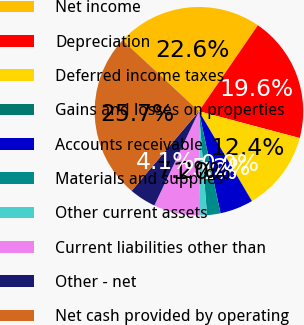<chart> <loc_0><loc_0><loc_500><loc_500><pie_chart><fcel>Net income<fcel>Depreciation<fcel>Deferred income taxes<fcel>Gains and losses on properties<fcel>Accounts receivable<fcel>Materials and supplies<fcel>Other current assets<fcel>Current liabilities other than<fcel>Other - net<fcel>Net cash provided by operating<nl><fcel>22.65%<fcel>19.57%<fcel>12.37%<fcel>0.02%<fcel>5.16%<fcel>2.08%<fcel>1.05%<fcel>7.22%<fcel>4.14%<fcel>25.74%<nl></chart> 